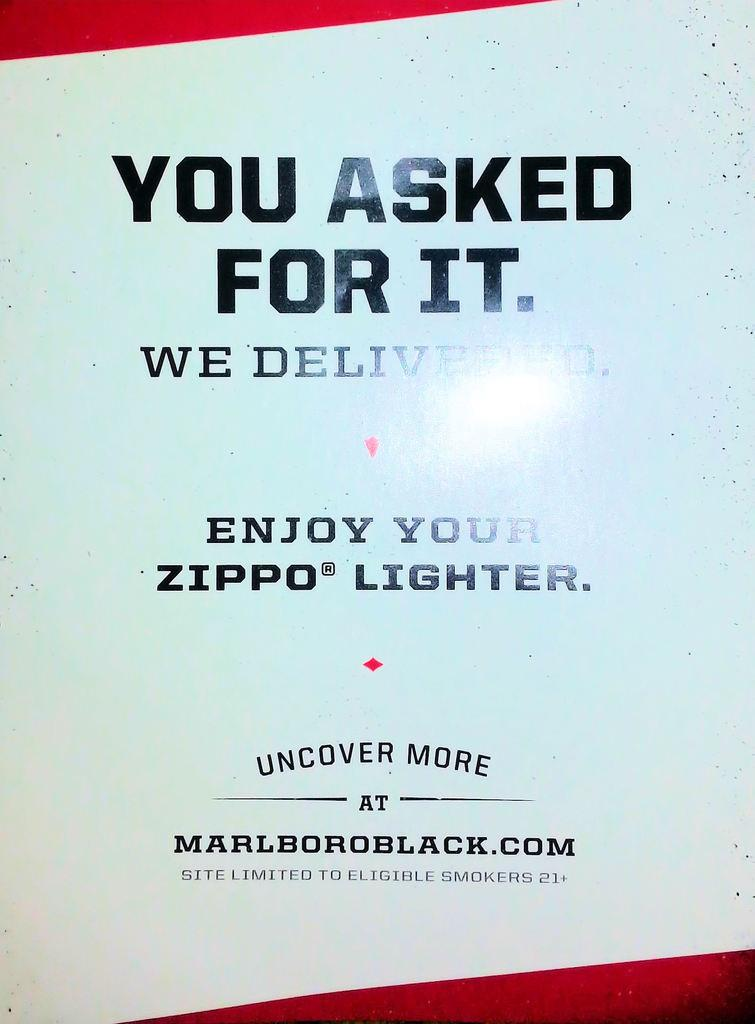<image>
Summarize the visual content of the image. An ad for Marlboro also includes a Zippo lighter. 